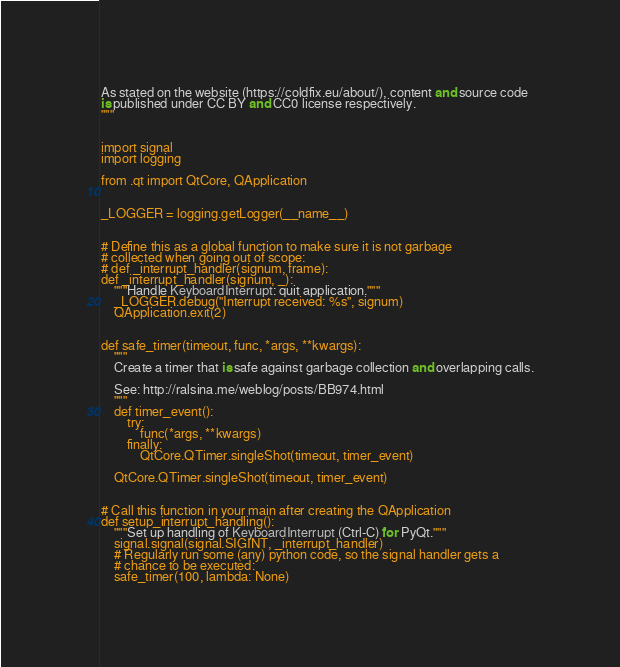Convert code to text. <code><loc_0><loc_0><loc_500><loc_500><_Python_>
As stated on the website (https://coldfix.eu/about/), content and source code
is published under CC BY and CC0 license respectively.
"""


import signal
import logging

from .qt import QtCore, QApplication


_LOGGER = logging.getLogger(__name__)


# Define this as a global function to make sure it is not garbage
# collected when going out of scope:
# def _interrupt_handler(signum, frame):
def _interrupt_handler(signum, _):
    """Handle KeyboardInterrupt: quit application."""
    _LOGGER.debug("Interrupt received: %s", signum)
    QApplication.exit(2)


def safe_timer(timeout, func, *args, **kwargs):
    """
    Create a timer that is safe against garbage collection and overlapping calls.

    See: http://ralsina.me/weblog/posts/BB974.html
    """
    def timer_event():
        try:
            func(*args, **kwargs)
        finally:
            QtCore.QTimer.singleShot(timeout, timer_event)

    QtCore.QTimer.singleShot(timeout, timer_event)


# Call this function in your main after creating the QApplication
def setup_interrupt_handling():
    """Set up handling of KeyboardInterrupt (Ctrl-C) for PyQt."""
    signal.signal(signal.SIGINT, _interrupt_handler)
    # Regularly run some (any) python code, so the signal handler gets a
    # chance to be executed:
    safe_timer(100, lambda: None)
</code> 